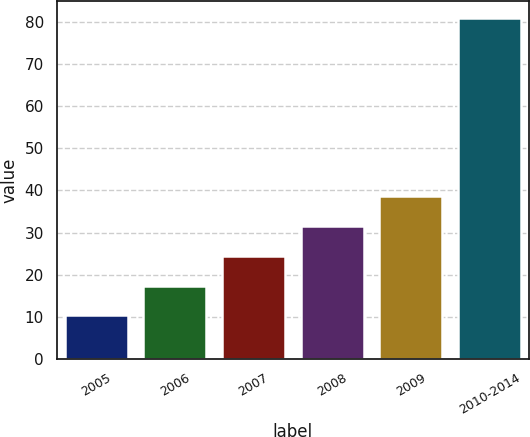Convert chart. <chart><loc_0><loc_0><loc_500><loc_500><bar_chart><fcel>2005<fcel>2006<fcel>2007<fcel>2008<fcel>2009<fcel>2010-2014<nl><fcel>10.3<fcel>17.37<fcel>24.44<fcel>31.51<fcel>38.58<fcel>81<nl></chart> 